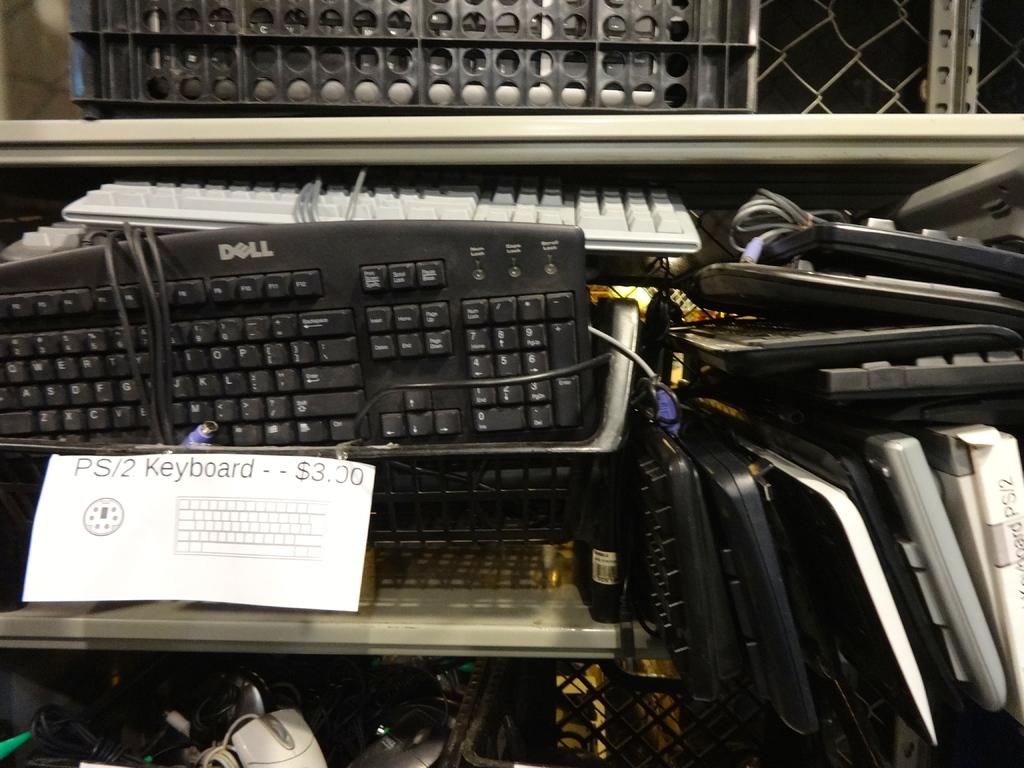How much are the keyboards?
Your answer should be compact. $3.00. What brand of keyboard?
Offer a terse response. Dell. 